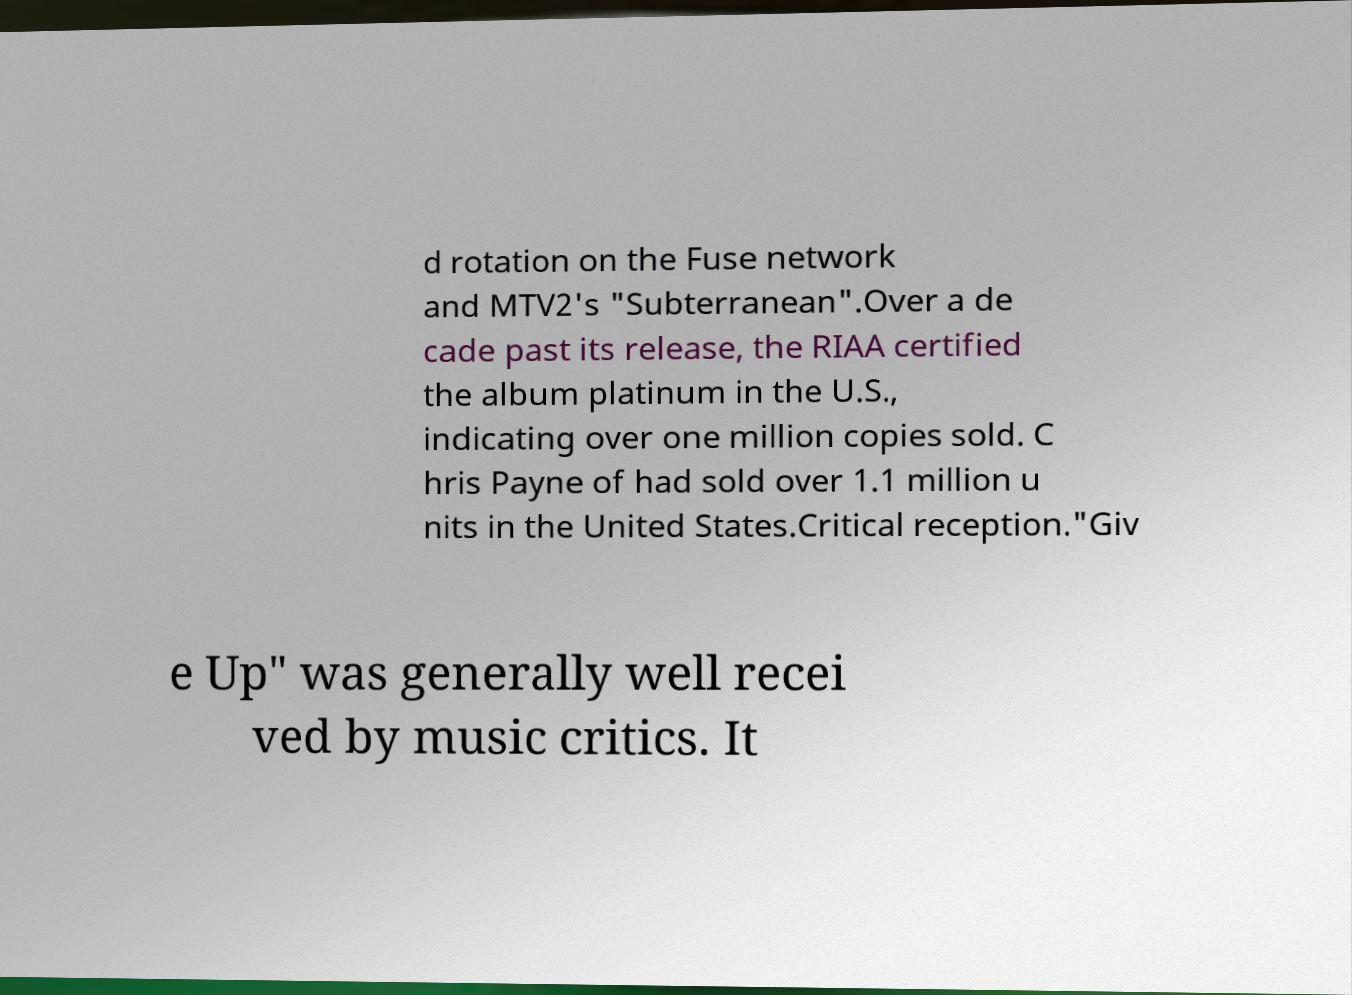What messages or text are displayed in this image? I need them in a readable, typed format. d rotation on the Fuse network and MTV2's "Subterranean".Over a de cade past its release, the RIAA certified the album platinum in the U.S., indicating over one million copies sold. C hris Payne of had sold over 1.1 million u nits in the United States.Critical reception."Giv e Up" was generally well recei ved by music critics. It 